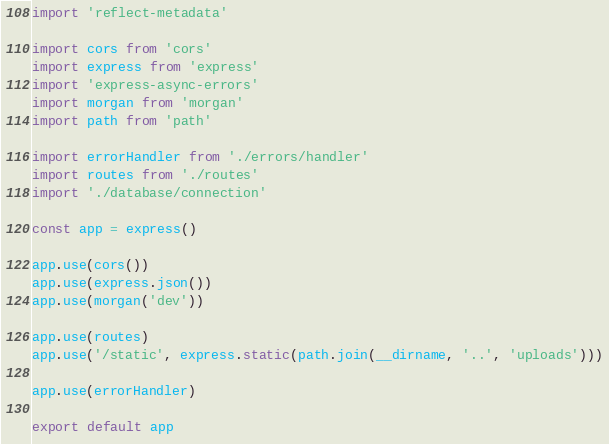Convert code to text. <code><loc_0><loc_0><loc_500><loc_500><_TypeScript_>import 'reflect-metadata'

import cors from 'cors'
import express from 'express'
import 'express-async-errors'
import morgan from 'morgan'
import path from 'path'

import errorHandler from './errors/handler'
import routes from './routes'
import './database/connection'

const app = express()

app.use(cors())
app.use(express.json())
app.use(morgan('dev'))

app.use(routes)
app.use('/static', express.static(path.join(__dirname, '..', 'uploads')))

app.use(errorHandler)

export default app
</code> 